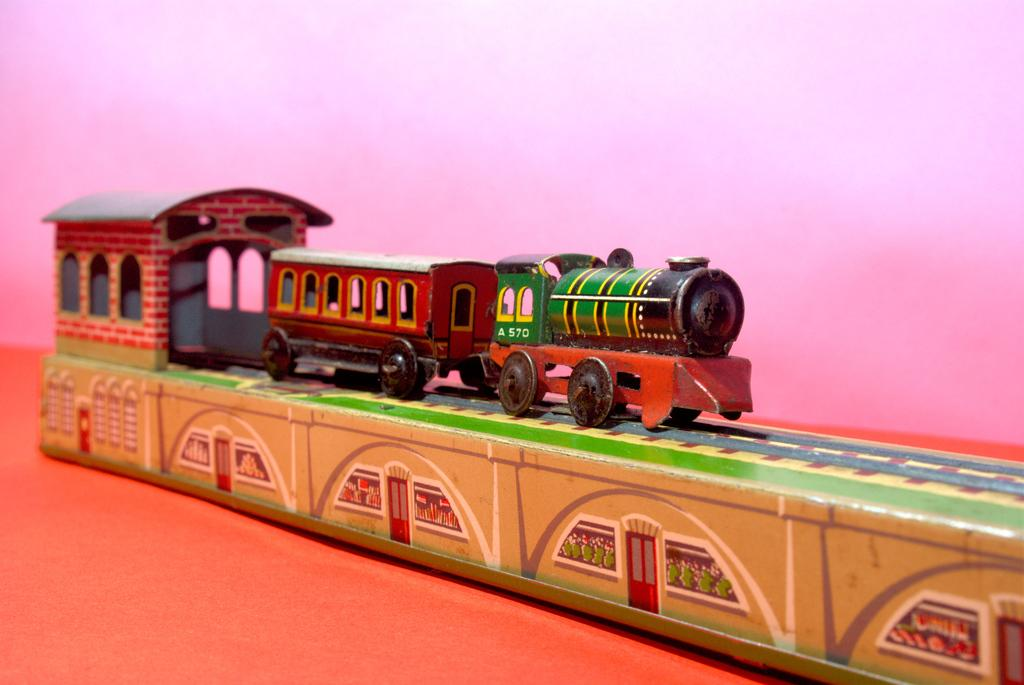What type of toy is in the image? The toy in the image is a train. What is the train doing in the image? The train is on a train track. What can be seen in the background of the image? There is a wall in the image. What is the train resting on in the image? The train is on the floor in the image. What type of coil is present in the image? There is no coil present in the image. What is the limit of the train's movement in the image? The train is stationary on the train track, so there is no limit to its movement in the image. 